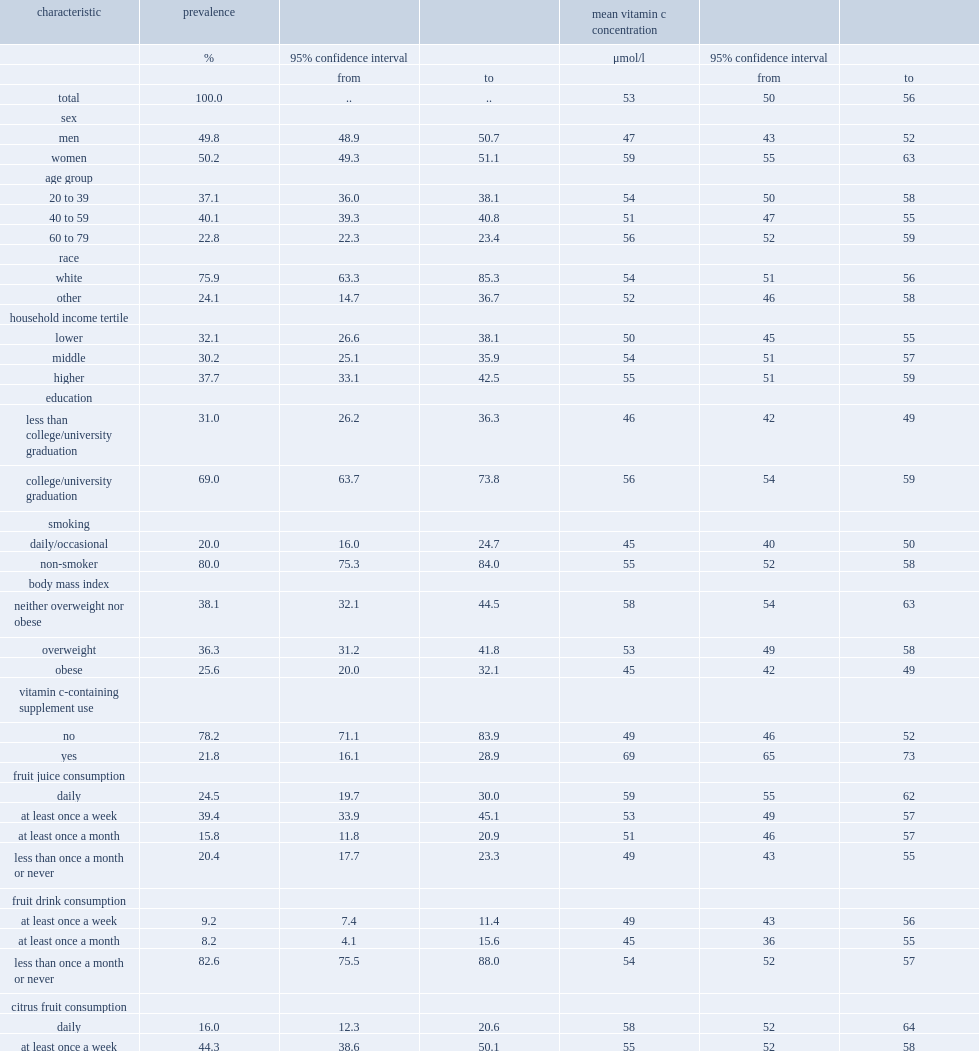What was the percentage of individuals reported having taken a vitamin c-containing supplement in the previous month? 21.8. What was the percentage of individuals drank fruit juice daily? 24.5. What was the percentage of individuals ate citrus fruit daily? 16.0. What was the mean plasma vitamin c concentration of canadians aged 20 to 79? 53.666667. What was the difference between users of vitamin c-containing supplements of mean concentrations and those of non-users? 20. What was the prevalence of individuals were men? 49.8. What was the prevalence of individuals were daily or occasional smokers? 20.0. What was the prevalence of individuals were obese? 25.6. 